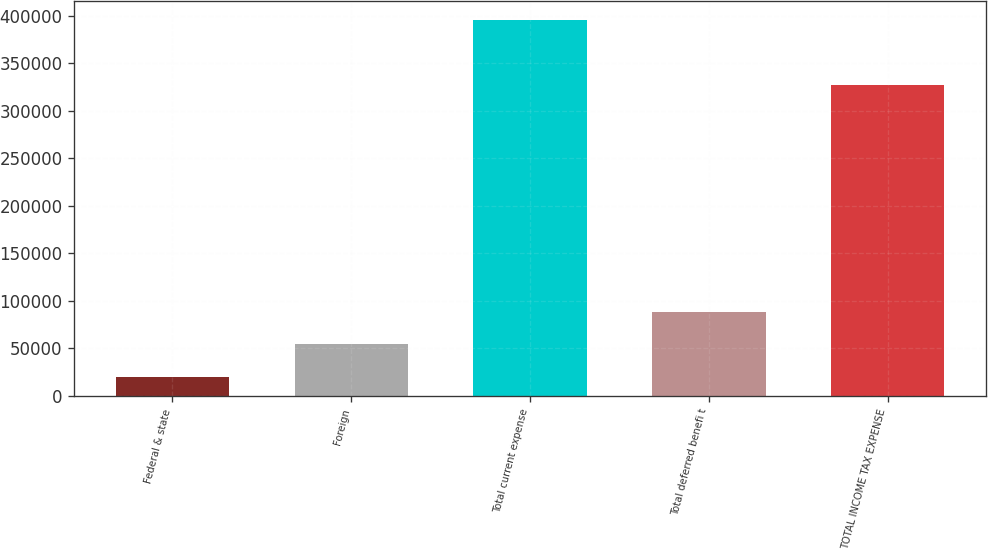Convert chart. <chart><loc_0><loc_0><loc_500><loc_500><bar_chart><fcel>Federal & state<fcel>Foreign<fcel>Total current expense<fcel>Total deferred benefi t<fcel>TOTAL INCOME TAX EXPENSE<nl><fcel>19962<fcel>54274.1<fcel>395891<fcel>88586.2<fcel>327267<nl></chart> 